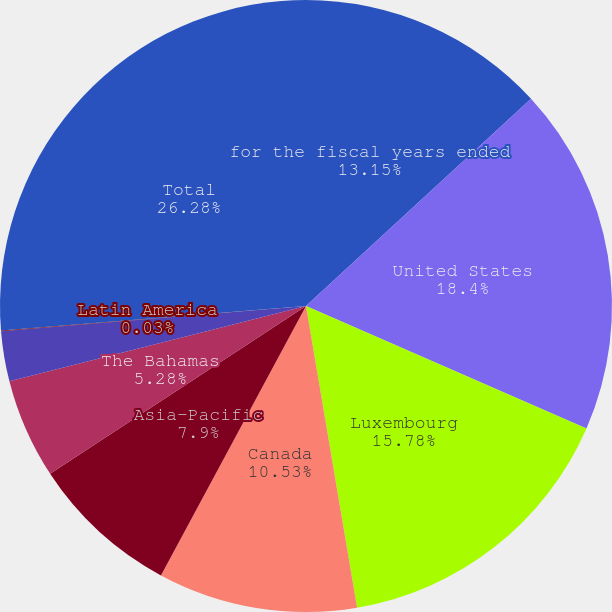<chart> <loc_0><loc_0><loc_500><loc_500><pie_chart><fcel>for the fiscal years ended<fcel>United States<fcel>Luxembourg<fcel>Canada<fcel>Asia-Pacific<fcel>The Bahamas<fcel>Europe the Middle East and<fcel>Latin America<fcel>Total<nl><fcel>13.15%<fcel>18.4%<fcel>15.78%<fcel>10.53%<fcel>7.9%<fcel>5.28%<fcel>2.65%<fcel>0.03%<fcel>26.28%<nl></chart> 